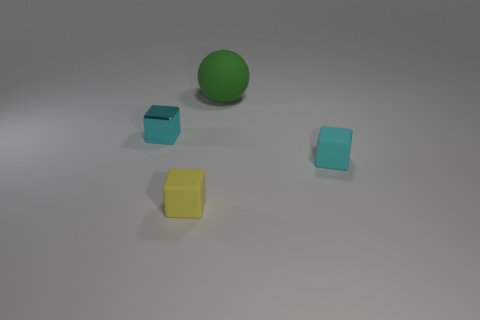Is there a tiny rubber thing of the same color as the small metal thing? yes 